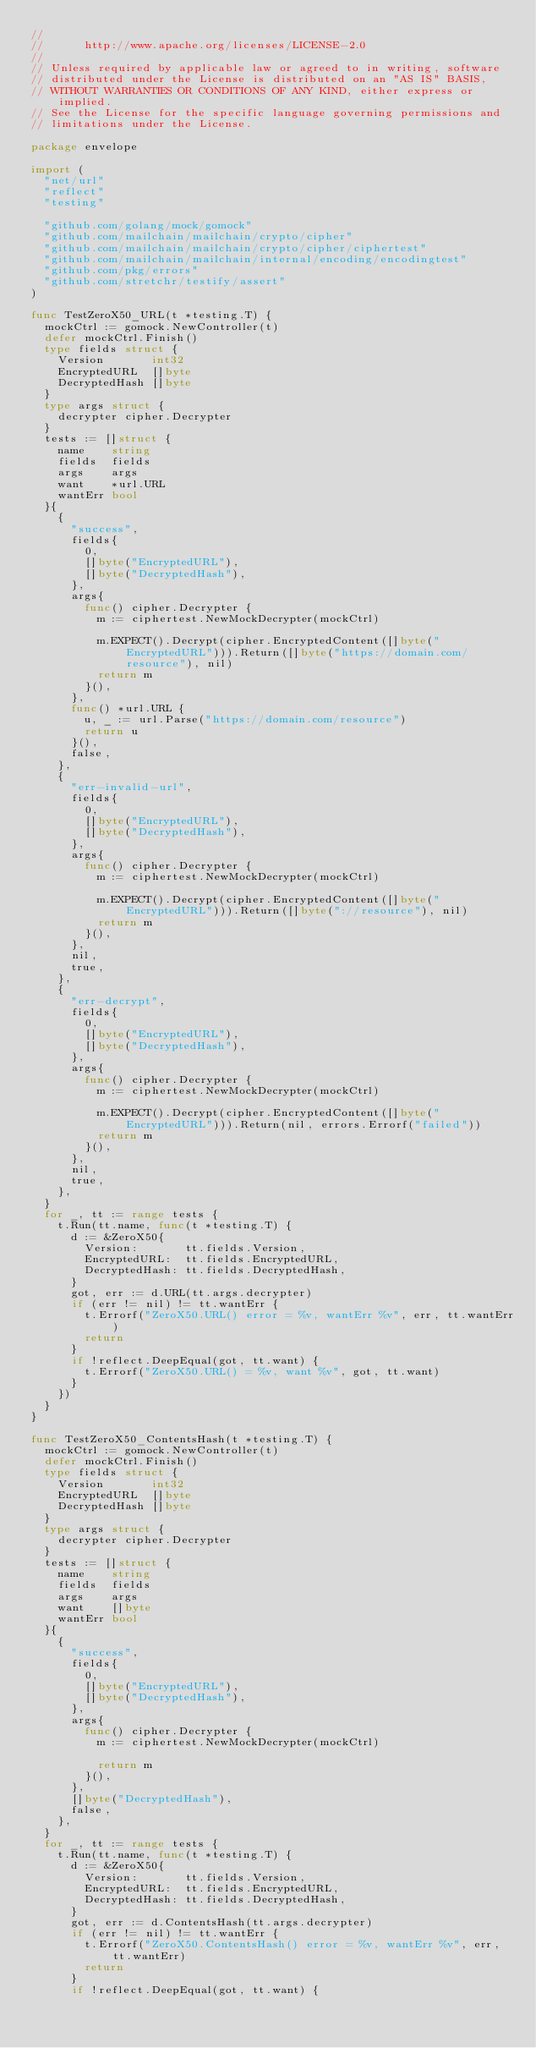Convert code to text. <code><loc_0><loc_0><loc_500><loc_500><_Go_>//
//      http://www.apache.org/licenses/LICENSE-2.0
//
// Unless required by applicable law or agreed to in writing, software
// distributed under the License is distributed on an "AS IS" BASIS,
// WITHOUT WARRANTIES OR CONDITIONS OF ANY KIND, either express or implied.
// See the License for the specific language governing permissions and
// limitations under the License.

package envelope

import (
	"net/url"
	"reflect"
	"testing"

	"github.com/golang/mock/gomock"
	"github.com/mailchain/mailchain/crypto/cipher"
	"github.com/mailchain/mailchain/crypto/cipher/ciphertest"
	"github.com/mailchain/mailchain/internal/encoding/encodingtest"
	"github.com/pkg/errors"
	"github.com/stretchr/testify/assert"
)

func TestZeroX50_URL(t *testing.T) {
	mockCtrl := gomock.NewController(t)
	defer mockCtrl.Finish()
	type fields struct {
		Version       int32
		EncryptedURL  []byte
		DecryptedHash []byte
	}
	type args struct {
		decrypter cipher.Decrypter
	}
	tests := []struct {
		name    string
		fields  fields
		args    args
		want    *url.URL
		wantErr bool
	}{
		{
			"success",
			fields{
				0,
				[]byte("EncryptedURL"),
				[]byte("DecryptedHash"),
			},
			args{
				func() cipher.Decrypter {
					m := ciphertest.NewMockDecrypter(mockCtrl)

					m.EXPECT().Decrypt(cipher.EncryptedContent([]byte("EncryptedURL"))).Return([]byte("https://domain.com/resource"), nil)
					return m
				}(),
			},
			func() *url.URL {
				u, _ := url.Parse("https://domain.com/resource")
				return u
			}(),
			false,
		},
		{
			"err-invalid-url",
			fields{
				0,
				[]byte("EncryptedURL"),
				[]byte("DecryptedHash"),
			},
			args{
				func() cipher.Decrypter {
					m := ciphertest.NewMockDecrypter(mockCtrl)

					m.EXPECT().Decrypt(cipher.EncryptedContent([]byte("EncryptedURL"))).Return([]byte("://resource"), nil)
					return m
				}(),
			},
			nil,
			true,
		},
		{
			"err-decrypt",
			fields{
				0,
				[]byte("EncryptedURL"),
				[]byte("DecryptedHash"),
			},
			args{
				func() cipher.Decrypter {
					m := ciphertest.NewMockDecrypter(mockCtrl)

					m.EXPECT().Decrypt(cipher.EncryptedContent([]byte("EncryptedURL"))).Return(nil, errors.Errorf("failed"))
					return m
				}(),
			},
			nil,
			true,
		},
	}
	for _, tt := range tests {
		t.Run(tt.name, func(t *testing.T) {
			d := &ZeroX50{
				Version:       tt.fields.Version,
				EncryptedURL:  tt.fields.EncryptedURL,
				DecryptedHash: tt.fields.DecryptedHash,
			}
			got, err := d.URL(tt.args.decrypter)
			if (err != nil) != tt.wantErr {
				t.Errorf("ZeroX50.URL() error = %v, wantErr %v", err, tt.wantErr)
				return
			}
			if !reflect.DeepEqual(got, tt.want) {
				t.Errorf("ZeroX50.URL() = %v, want %v", got, tt.want)
			}
		})
	}
}

func TestZeroX50_ContentsHash(t *testing.T) {
	mockCtrl := gomock.NewController(t)
	defer mockCtrl.Finish()
	type fields struct {
		Version       int32
		EncryptedURL  []byte
		DecryptedHash []byte
	}
	type args struct {
		decrypter cipher.Decrypter
	}
	tests := []struct {
		name    string
		fields  fields
		args    args
		want    []byte
		wantErr bool
	}{
		{
			"success",
			fields{
				0,
				[]byte("EncryptedURL"),
				[]byte("DecryptedHash"),
			},
			args{
				func() cipher.Decrypter {
					m := ciphertest.NewMockDecrypter(mockCtrl)

					return m
				}(),
			},
			[]byte("DecryptedHash"),
			false,
		},
	}
	for _, tt := range tests {
		t.Run(tt.name, func(t *testing.T) {
			d := &ZeroX50{
				Version:       tt.fields.Version,
				EncryptedURL:  tt.fields.EncryptedURL,
				DecryptedHash: tt.fields.DecryptedHash,
			}
			got, err := d.ContentsHash(tt.args.decrypter)
			if (err != nil) != tt.wantErr {
				t.Errorf("ZeroX50.ContentsHash() error = %v, wantErr %v", err, tt.wantErr)
				return
			}
			if !reflect.DeepEqual(got, tt.want) {</code> 